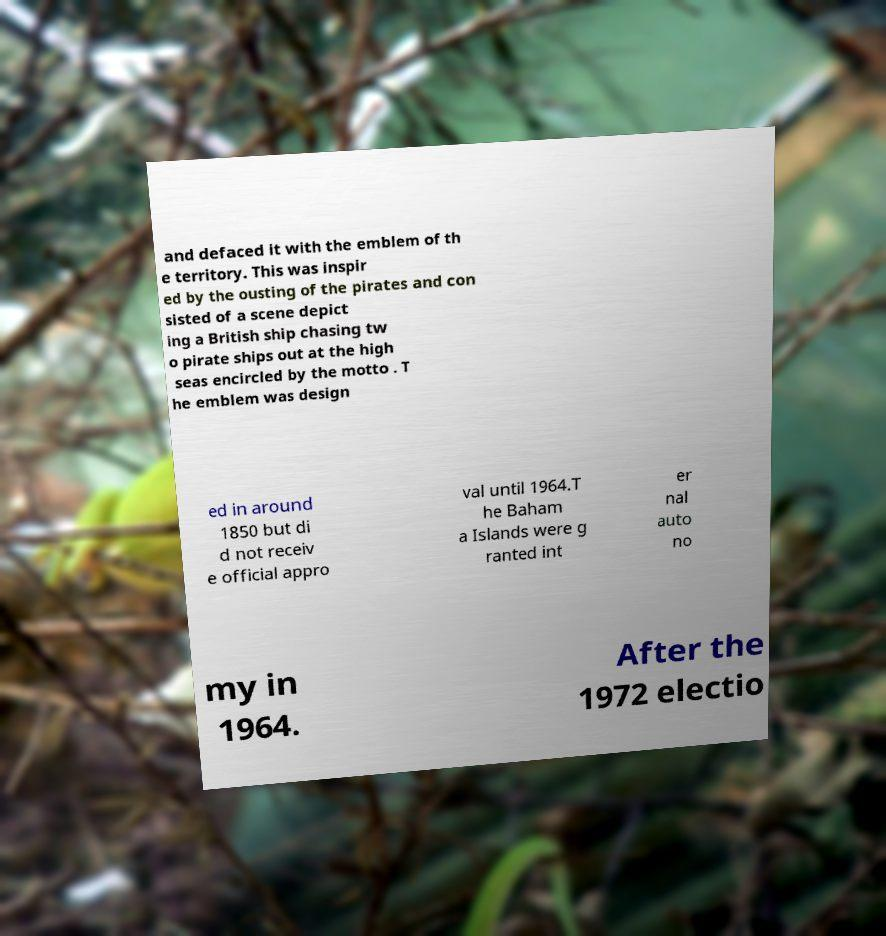Please identify and transcribe the text found in this image. and defaced it with the emblem of th e territory. This was inspir ed by the ousting of the pirates and con sisted of a scene depict ing a British ship chasing tw o pirate ships out at the high seas encircled by the motto . T he emblem was design ed in around 1850 but di d not receiv e official appro val until 1964.T he Baham a Islands were g ranted int er nal auto no my in 1964. After the 1972 electio 